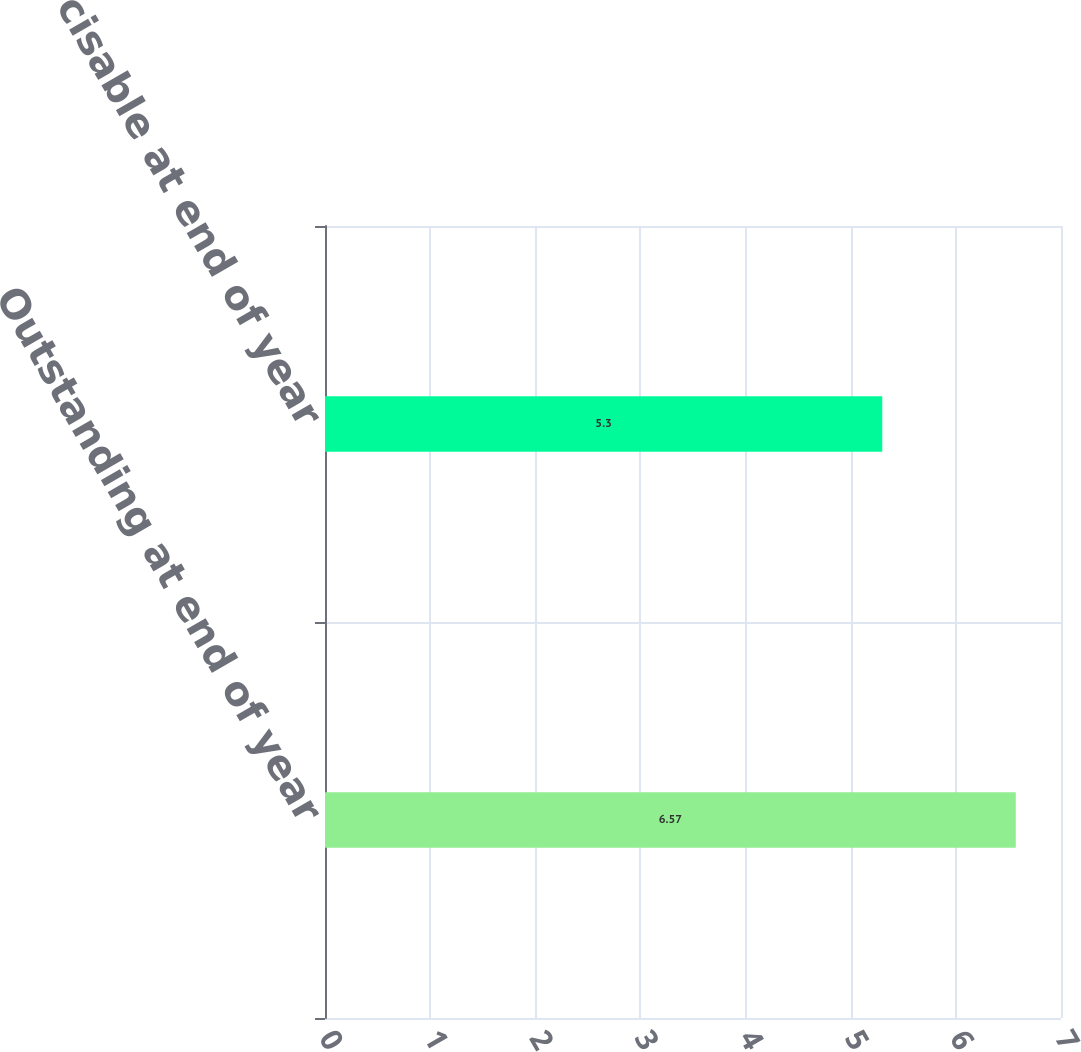Convert chart to OTSL. <chart><loc_0><loc_0><loc_500><loc_500><bar_chart><fcel>Outstanding at end of year<fcel>Exercisable at end of year<nl><fcel>6.57<fcel>5.3<nl></chart> 